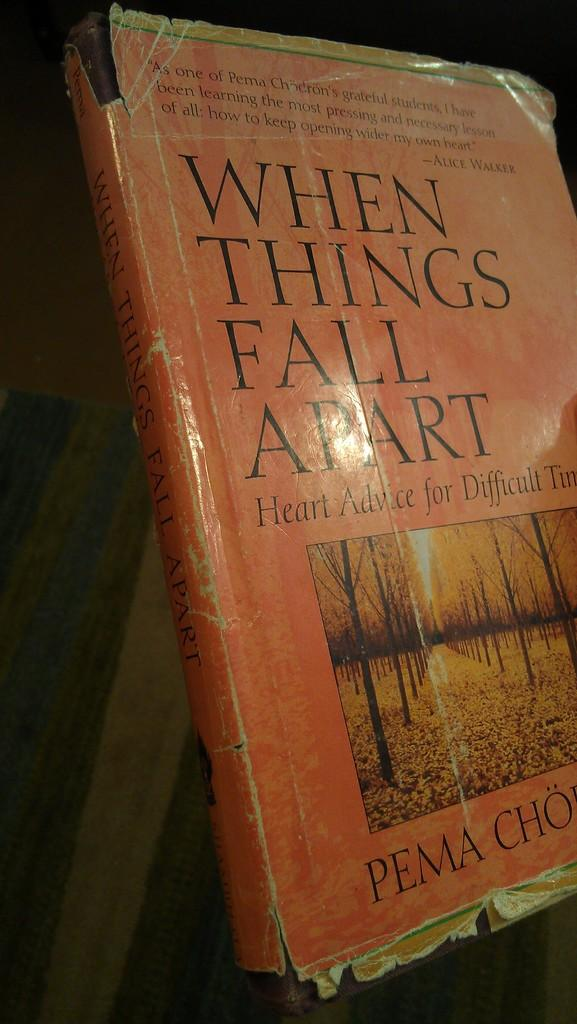<image>
Summarize the visual content of the image. A book with an orange cover talking about things falling apart. 